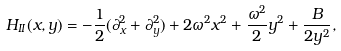<formula> <loc_0><loc_0><loc_500><loc_500>H _ { I I } ( x , y ) = - \frac { 1 } { 2 } ( \partial _ { x } ^ { 2 } + \partial _ { y } ^ { 2 } ) + 2 \omega ^ { 2 } x ^ { 2 } + \frac { \omega ^ { 2 } } { 2 } y ^ { 2 } + \frac { B } { 2 y ^ { 2 } } ,</formula> 